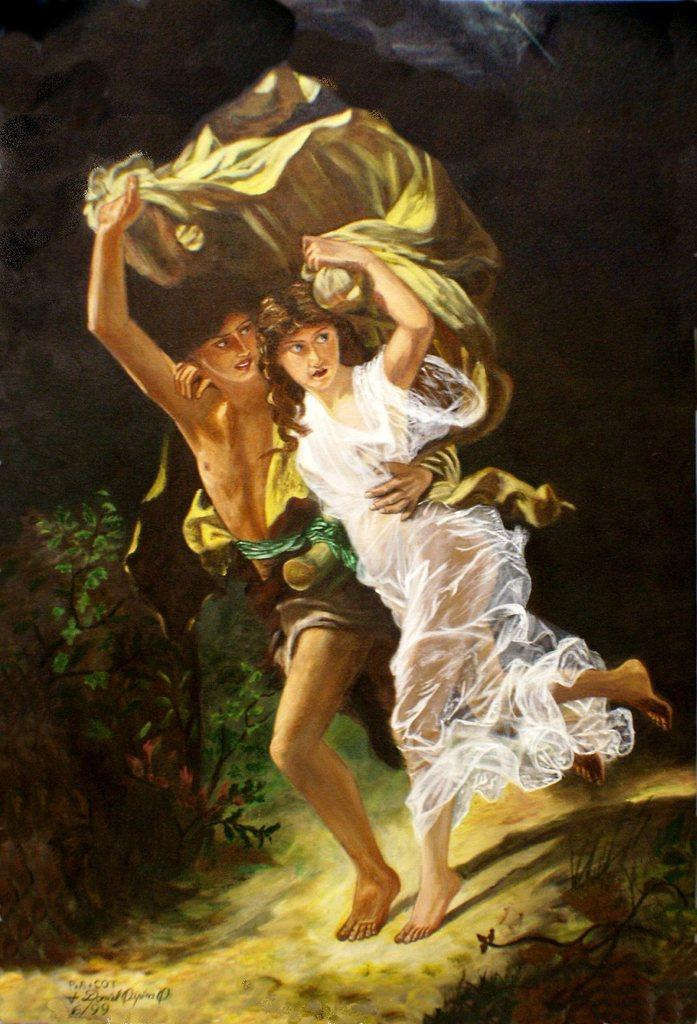How many people are in the image? There are two people standing in the image. What are the people holding in the image? The people are holding something, but the specific object is not mentioned in the facts. What colors are the dresses of the people in the image? The people are wearing different color dresses. What colors can be seen in the background of the image? The background of the image is black and brown. What type of vegetation is visible in the image? There are green plants visible in the image. Can you see any icicles hanging from the plants in the image? There is no mention of icicles in the image, and the presence of green plants suggests a warmer environment where icicles would not be present. 